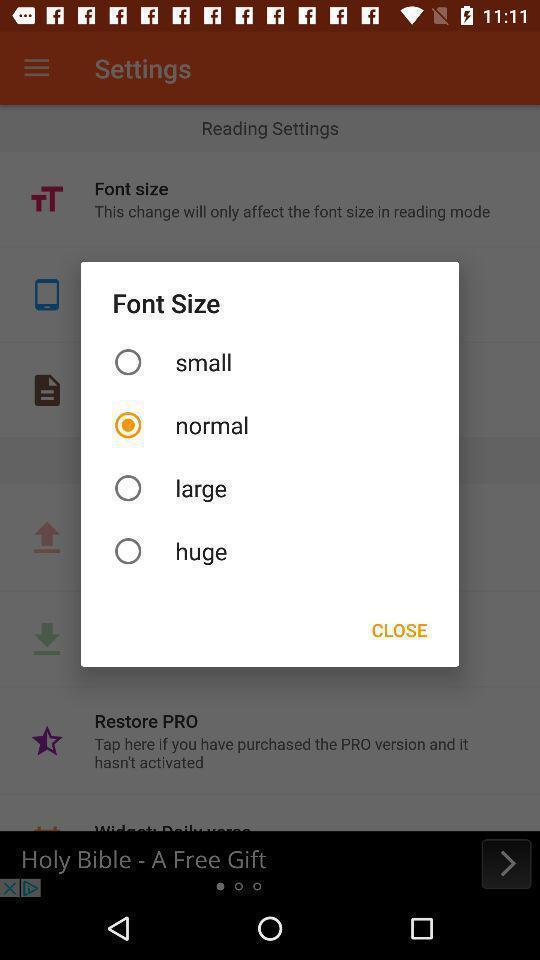Tell me what you see in this picture. Popup to choose an option. 